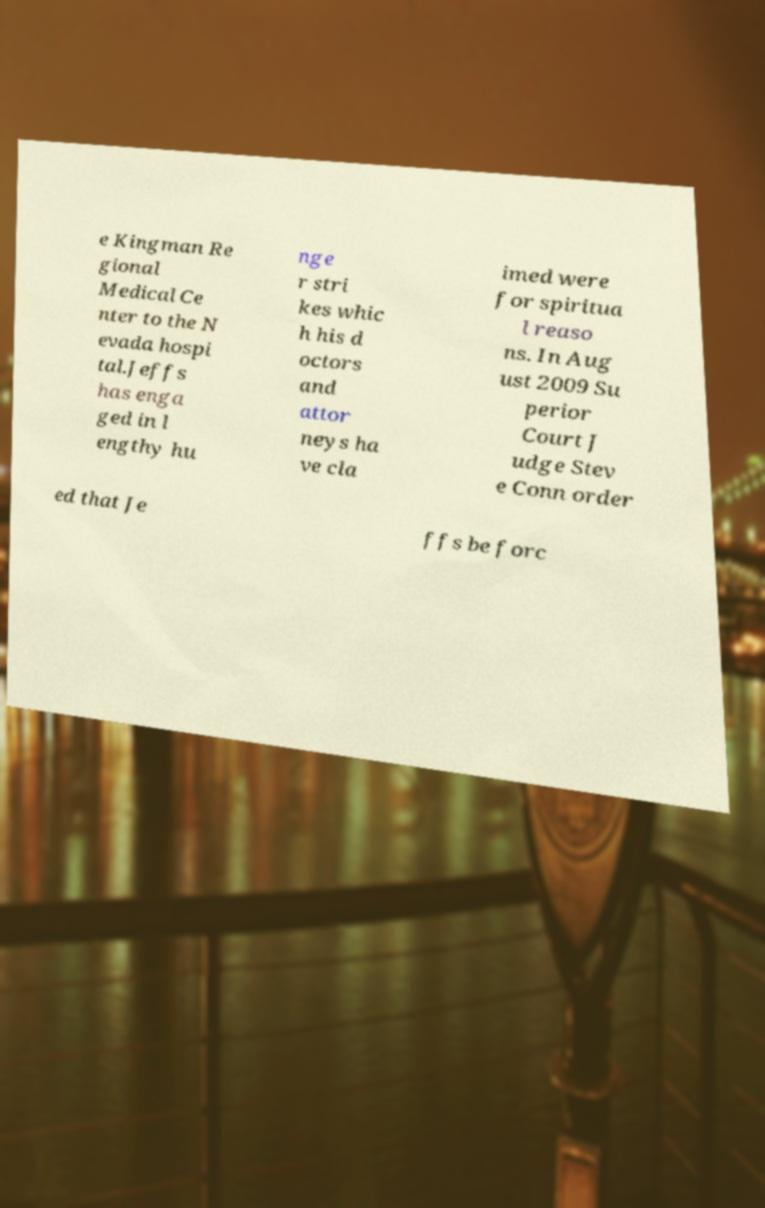There's text embedded in this image that I need extracted. Can you transcribe it verbatim? e Kingman Re gional Medical Ce nter to the N evada hospi tal.Jeffs has enga ged in l engthy hu nge r stri kes whic h his d octors and attor neys ha ve cla imed were for spiritua l reaso ns. In Aug ust 2009 Su perior Court J udge Stev e Conn order ed that Je ffs be forc 